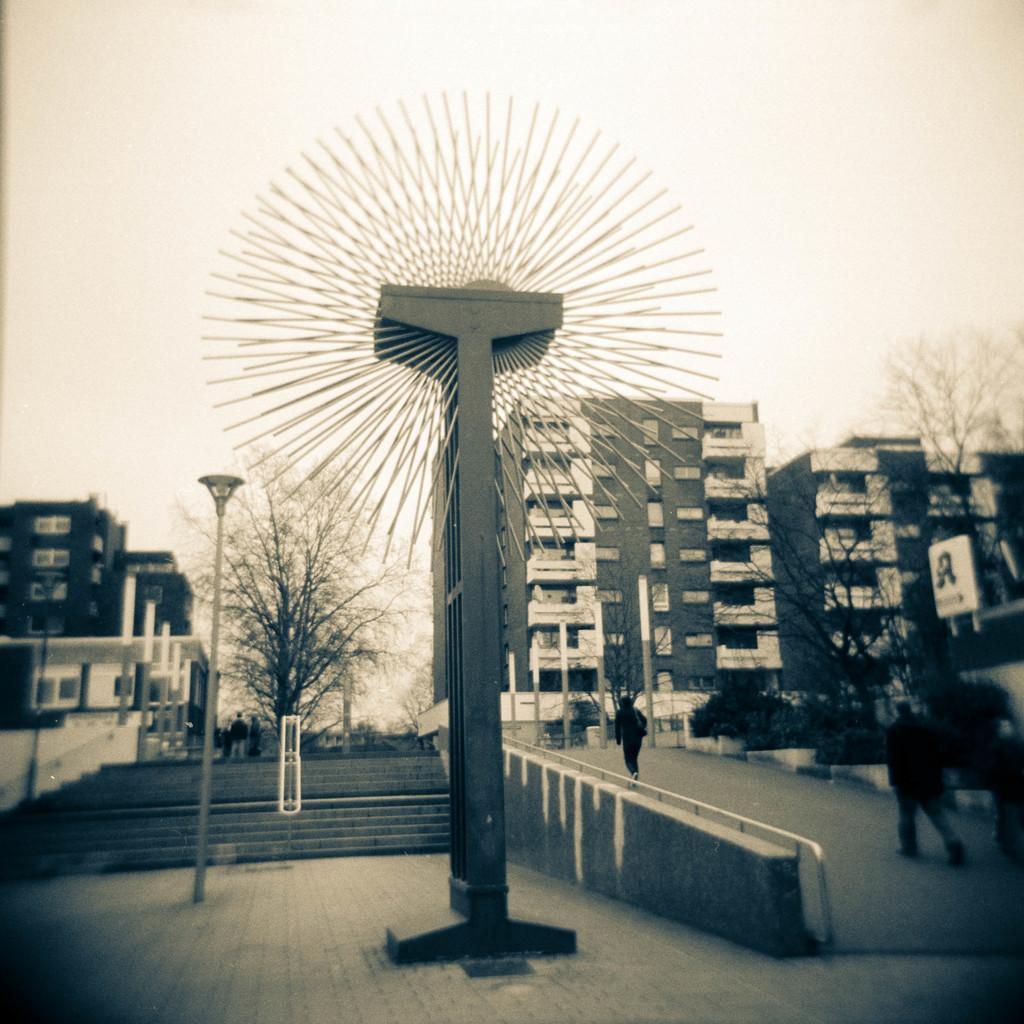Describe this image in one or two sentences. In the middle of this image, there are sticks in circular shape, arranged. These are attached to a pole. Beside this all, there is a fence. On the left side, there is another pole. Beside this poll, there are steps. On the right side, there are persons walking on a road. In the background, there are buildings, trees and there are clouds in the sky. 